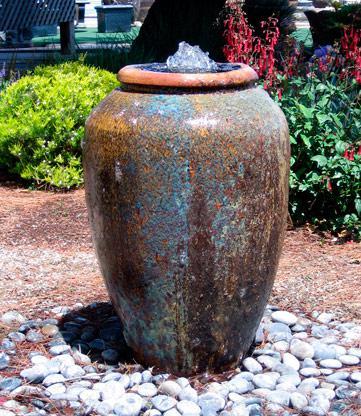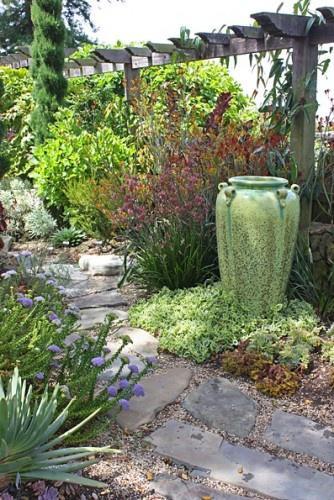The first image is the image on the left, the second image is the image on the right. Analyze the images presented: Is the assertion "Each image features exactly one upright pottery vessel." valid? Answer yes or no. Yes. The first image is the image on the left, the second image is the image on the right. Assess this claim about the two images: "Two large urn shaped pots are placed in outdoor garden settings, with at least one being used as a water fountain.". Correct or not? Answer yes or no. Yes. 